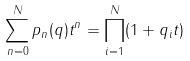Convert formula to latex. <formula><loc_0><loc_0><loc_500><loc_500>\sum ^ { N } _ { n = 0 } p _ { n } ( q ) t ^ { n } = \prod ^ { N } _ { i = 1 } ( 1 + q _ { i } t )</formula> 